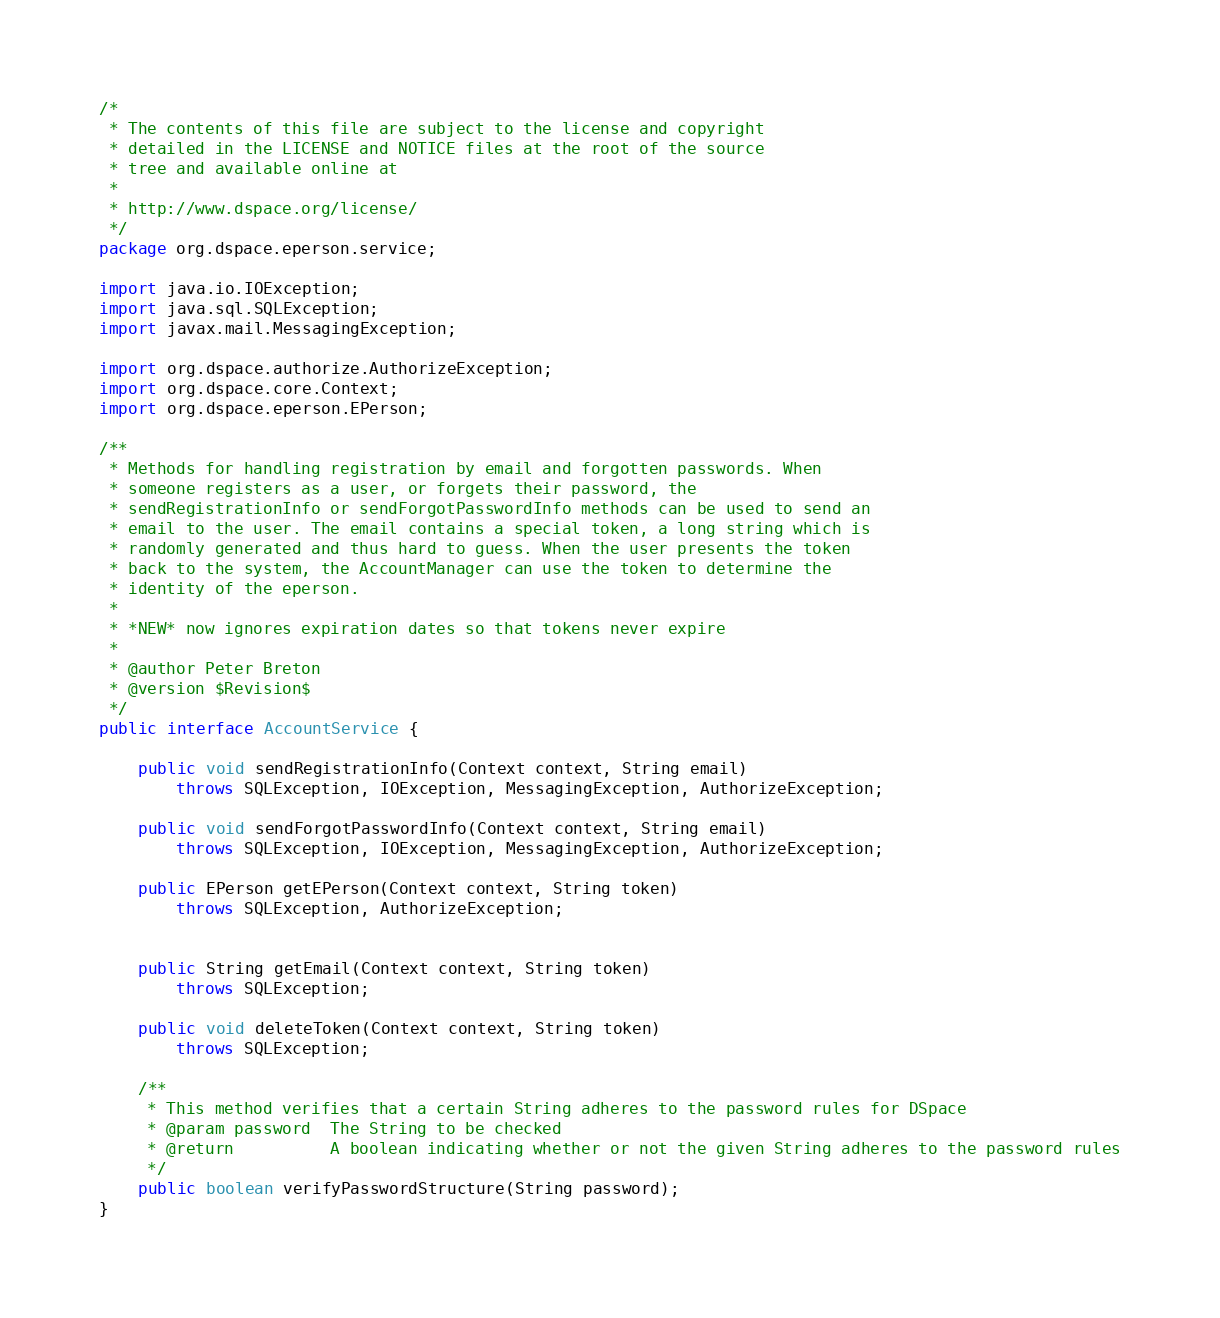Convert code to text. <code><loc_0><loc_0><loc_500><loc_500><_Java_>/*
 * The contents of this file are subject to the license and copyright
 * detailed in the LICENSE and NOTICE files at the root of the source
 * tree and available online at
 *
 * http://www.dspace.org/license/
 */
package org.dspace.eperson.service;

import java.io.IOException;
import java.sql.SQLException;
import javax.mail.MessagingException;

import org.dspace.authorize.AuthorizeException;
import org.dspace.core.Context;
import org.dspace.eperson.EPerson;

/**
 * Methods for handling registration by email and forgotten passwords. When
 * someone registers as a user, or forgets their password, the
 * sendRegistrationInfo or sendForgotPasswordInfo methods can be used to send an
 * email to the user. The email contains a special token, a long string which is
 * randomly generated and thus hard to guess. When the user presents the token
 * back to the system, the AccountManager can use the token to determine the
 * identity of the eperson.
 *
 * *NEW* now ignores expiration dates so that tokens never expire
 *
 * @author Peter Breton
 * @version $Revision$
 */
public interface AccountService {

    public void sendRegistrationInfo(Context context, String email)
        throws SQLException, IOException, MessagingException, AuthorizeException;

    public void sendForgotPasswordInfo(Context context, String email)
        throws SQLException, IOException, MessagingException, AuthorizeException;

    public EPerson getEPerson(Context context, String token)
        throws SQLException, AuthorizeException;


    public String getEmail(Context context, String token)
        throws SQLException;

    public void deleteToken(Context context, String token)
        throws SQLException;

    /**
     * This method verifies that a certain String adheres to the password rules for DSpace
     * @param password  The String to be checked
     * @return          A boolean indicating whether or not the given String adheres to the password rules
     */
    public boolean verifyPasswordStructure(String password);
}
</code> 